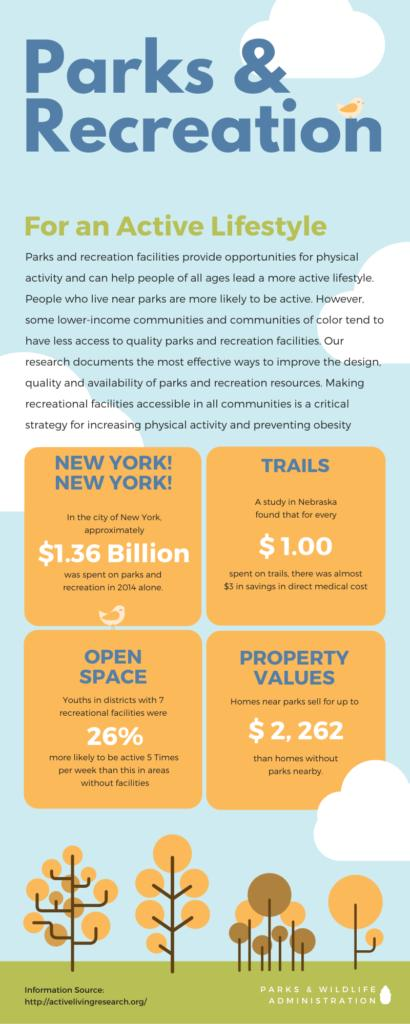List a handful of essential elements in this visual. The value of a home located near a park is typically higher than the value of a home without a park nearby, with a difference of $2,262 on average. The study found that for every dollar spent on trails, there is a 300% savings in direct medical costs. In 2014, the amount spent on parks and recreation in New York was $1.36 billion. 